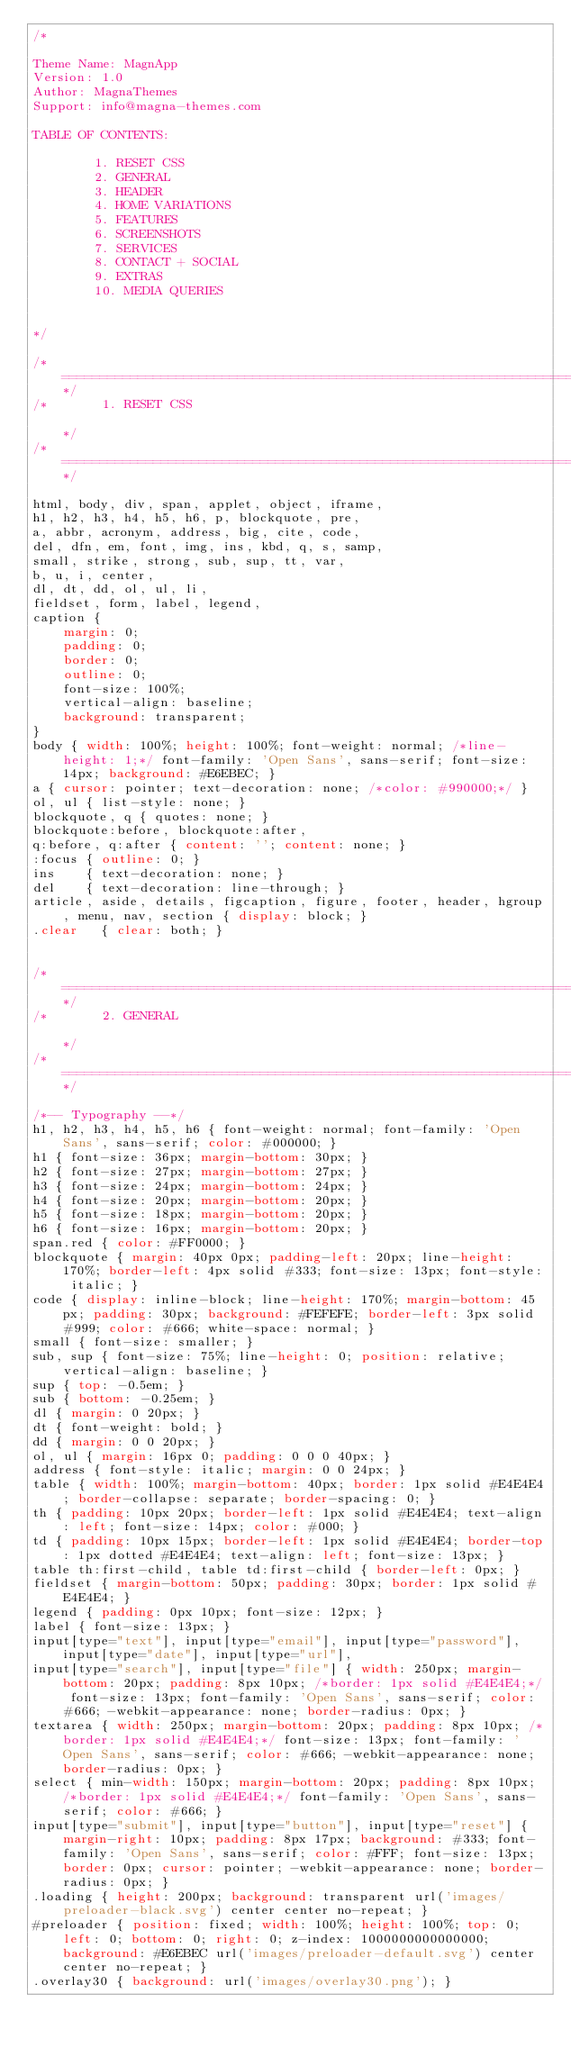Convert code to text. <code><loc_0><loc_0><loc_500><loc_500><_CSS_>/*

Theme Name: MagnApp
Version: 1.0
Author: MagnaThemes
Support: info@magna-themes.com

TABLE OF CONTENTS:

        1. RESET CSS
        2. GENERAL
        3. HEADER
        4. HOME VARIATIONS
        5. FEATURES
        6. SCREENSHOTS
        7. SERVICES
        8. CONTACT + SOCIAL
        9. EXTRAS
        10. MEDIA QUERIES


*/

/*=====================================================================================*/
/*       1. RESET CSS                                                                  */
/*=====================================================================================*/

html, body, div, span, applet, object, iframe,
h1, h2, h3, h4, h5, h6, p, blockquote, pre,
a, abbr, acronym, address, big, cite, code,
del, dfn, em, font, img, ins, kbd, q, s, samp,
small, strike, strong, sub, sup, tt, var,
b, u, i, center,
dl, dt, dd, ol, ul, li,
fieldset, form, label, legend,
caption {
	margin: 0;
	padding: 0;
	border: 0;
	outline: 0;
	font-size: 100%;
	vertical-align: baseline;
	background: transparent;
}
body { width: 100%; height: 100%; font-weight: normal; /*line-height: 1;*/ font-family: 'Open Sans', sans-serif; font-size: 14px; background: #E6EBEC; }
a { cursor: pointer; text-decoration: none; /*color: #990000;*/ }
ol, ul { list-style: none; }
blockquote, q { quotes: none; }
blockquote:before, blockquote:after,
q:before, q:after { content: ''; content: none; }
:focus { outline: 0; }
ins    { text-decoration: none; }
del    { text-decoration: line-through; }
article, aside, details, figcaption, figure, footer, header, hgroup, menu, nav, section { display: block; }
.clear   { clear: both; }


/*=====================================================================================*/
/*       2. GENERAL                                                                    */
/*=====================================================================================*/

/*-- Typography --*/
h1, h2, h3, h4, h5, h6 { font-weight: normal; font-family: 'Open Sans', sans-serif; color: #000000; }
h1 { font-size: 36px; margin-bottom: 30px; }
h2 { font-size: 27px; margin-bottom: 27px; }
h3 { font-size: 24px; margin-bottom: 24px; }
h4 { font-size: 20px; margin-bottom: 20px; }
h5 { font-size: 18px; margin-bottom: 20px; }
h6 { font-size: 16px; margin-bottom: 20px; }
span.red { color: #FF0000; }
blockquote { margin: 40px 0px; padding-left: 20px; line-height: 170%; border-left: 4px solid #333; font-size: 13px; font-style: italic; }
code { display: inline-block; line-height: 170%; margin-bottom: 45px; padding: 30px; background: #FEFEFE; border-left: 3px solid #999; color: #666; white-space: normal; }
small { font-size: smaller; }
sub, sup { font-size: 75%; line-height: 0; position: relative; vertical-align: baseline; }
sup { top: -0.5em; }
sub { bottom: -0.25em; }
dl { margin: 0 20px; }
dt { font-weight: bold; }
dd { margin: 0 0 20px; }
ol, ul { margin: 16px 0; padding: 0 0 0 40px; }
address { font-style: italic; margin: 0 0 24px; }
table { width: 100%; margin-bottom: 40px; border: 1px solid #E4E4E4; border-collapse: separate; border-spacing: 0; }
th { padding: 10px 20px; border-left: 1px solid #E4E4E4; text-align: left; font-size: 14px; color: #000; }
td { padding: 10px 15px; border-left: 1px solid #E4E4E4; border-top: 1px dotted #E4E4E4; text-align: left; font-size: 13px; }
table th:first-child, table td:first-child { border-left: 0px; }
fieldset { margin-bottom: 50px; padding: 30px; border: 1px solid #E4E4E4; }
legend { padding: 0px 10px; font-size: 12px; }
label { font-size: 13px; }
input[type="text"], input[type="email"], input[type="password"], input[type="date"], input[type="url"],
input[type="search"], input[type="file"] { width: 250px; margin-bottom: 20px; padding: 8px 10px; /*border: 1px solid #E4E4E4;*/ font-size: 13px; font-family: 'Open Sans', sans-serif; color: #666; -webkit-appearance: none; border-radius: 0px; }
textarea { width: 250px; margin-bottom: 20px; padding: 8px 10px; /*border: 1px solid #E4E4E4;*/ font-size: 13px; font-family: 'Open Sans', sans-serif; color: #666; -webkit-appearance: none; border-radius: 0px; }
select { min-width: 150px; margin-bottom: 20px; padding: 8px 10px; /*border: 1px solid #E4E4E4;*/ font-family: 'Open Sans', sans-serif; color: #666; }
input[type="submit"], input[type="button"], input[type="reset"] { margin-right: 10px; padding: 8px 17px; background: #333; font-family: 'Open Sans', sans-serif; color: #FFF; font-size: 13px; border: 0px; cursor: pointer; -webkit-appearance: none; border-radius: 0px; }
.loading { height: 200px; background: transparent url('images/preloader-black.svg') center center no-repeat; }
#preloader { position: fixed; width: 100%; height: 100%; top: 0; left: 0; bottom: 0; right: 0; z-index: 1000000000000000; background: #E6EBEC url('images/preloader-default.svg') center center no-repeat; }
.overlay30 { background: url('images/overlay30.png'); }</code> 